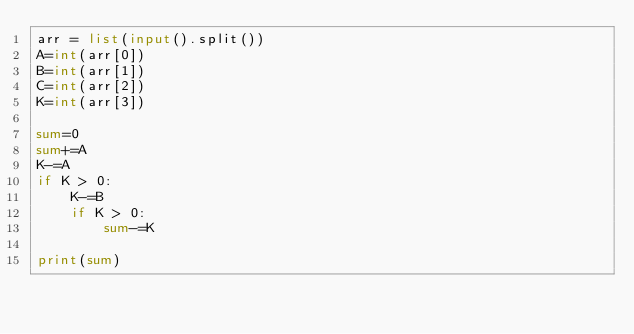Convert code to text. <code><loc_0><loc_0><loc_500><loc_500><_Python_>arr = list(input().split())
A=int(arr[0])
B=int(arr[1])
C=int(arr[2])
K=int(arr[3])

sum=0
sum+=A
K-=A
if K > 0:
	K-=B
	if K > 0:
		sum-=K

print(sum)

</code> 